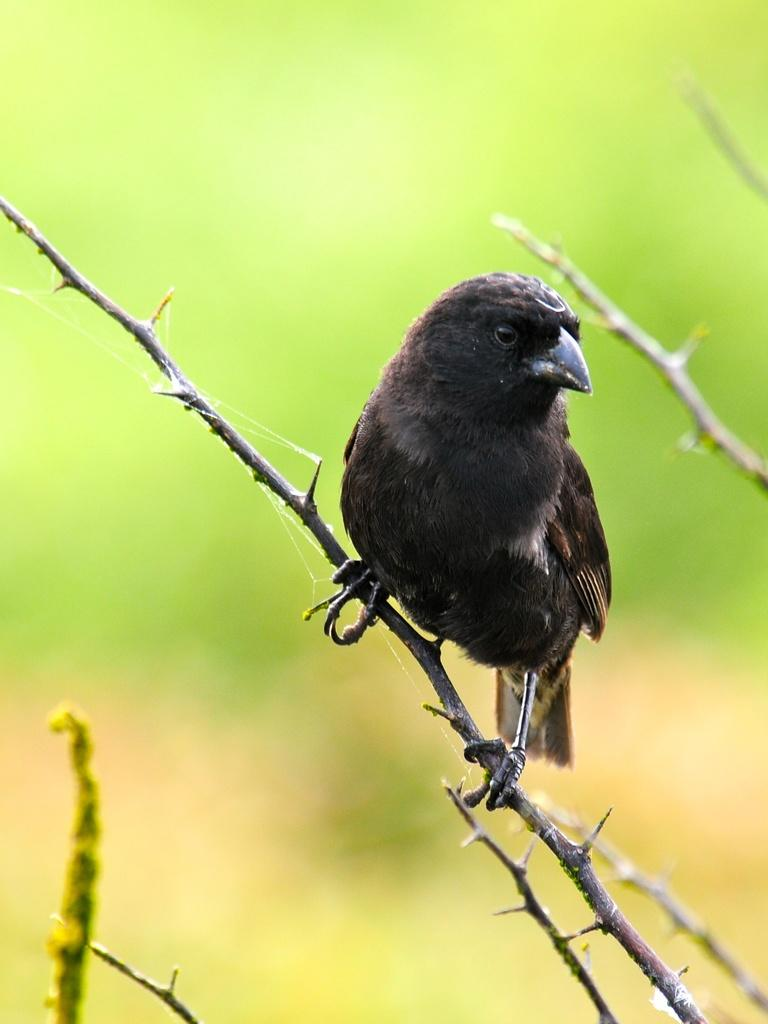What type of animal can be seen in the image? There is a bird in the image. Where is the bird located in the image? The bird is on a branch. Can you describe the background of the image? The background of the image is blurred. Reasoning: Let's think step by identifying the main subject in the image, which is the bird. Then, we expand the conversation to include the bird's location, which is on a branch. Finally, we describe the background of the image, which is blurred. Each question is designed to elicit a specific detail about the image that is known from the provided facts. Absurd Question/Answer: How many ants are visible on the bird's wing in the image? There are no ants visible on the bird's wing in the image. What type of dust can be seen on the bird's feathers in the image? There is no dust visible on the bird's feathers in the image. What type of wish can be granted by the bird in the image? There is no mention of wishes or any magical abilities in the image; it simply shows a bird on a branch. How many ants are visible on the bird's wing in the image? There are no ants visible on the bird's wing in the image. 